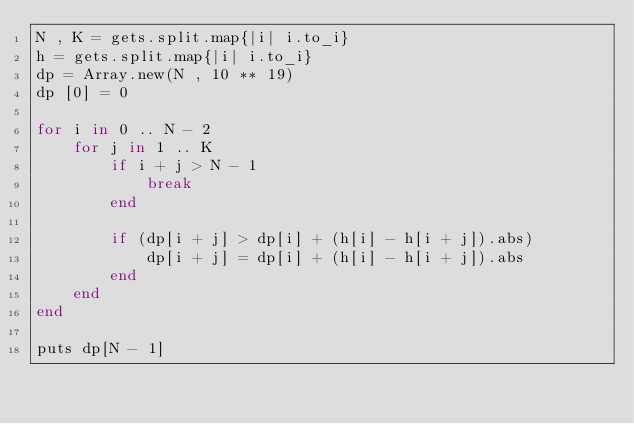<code> <loc_0><loc_0><loc_500><loc_500><_Ruby_>N , K = gets.split.map{|i| i.to_i}
h = gets.split.map{|i| i.to_i}
dp = Array.new(N , 10 ** 19)
dp [0] = 0

for i in 0 .. N - 2
    for j in 1 .. K
        if i + j > N - 1
            break
        end

        if (dp[i + j] > dp[i] + (h[i] - h[i + j]).abs)
            dp[i + j] = dp[i] + (h[i] - h[i + j]).abs
        end
    end
end

puts dp[N - 1]</code> 